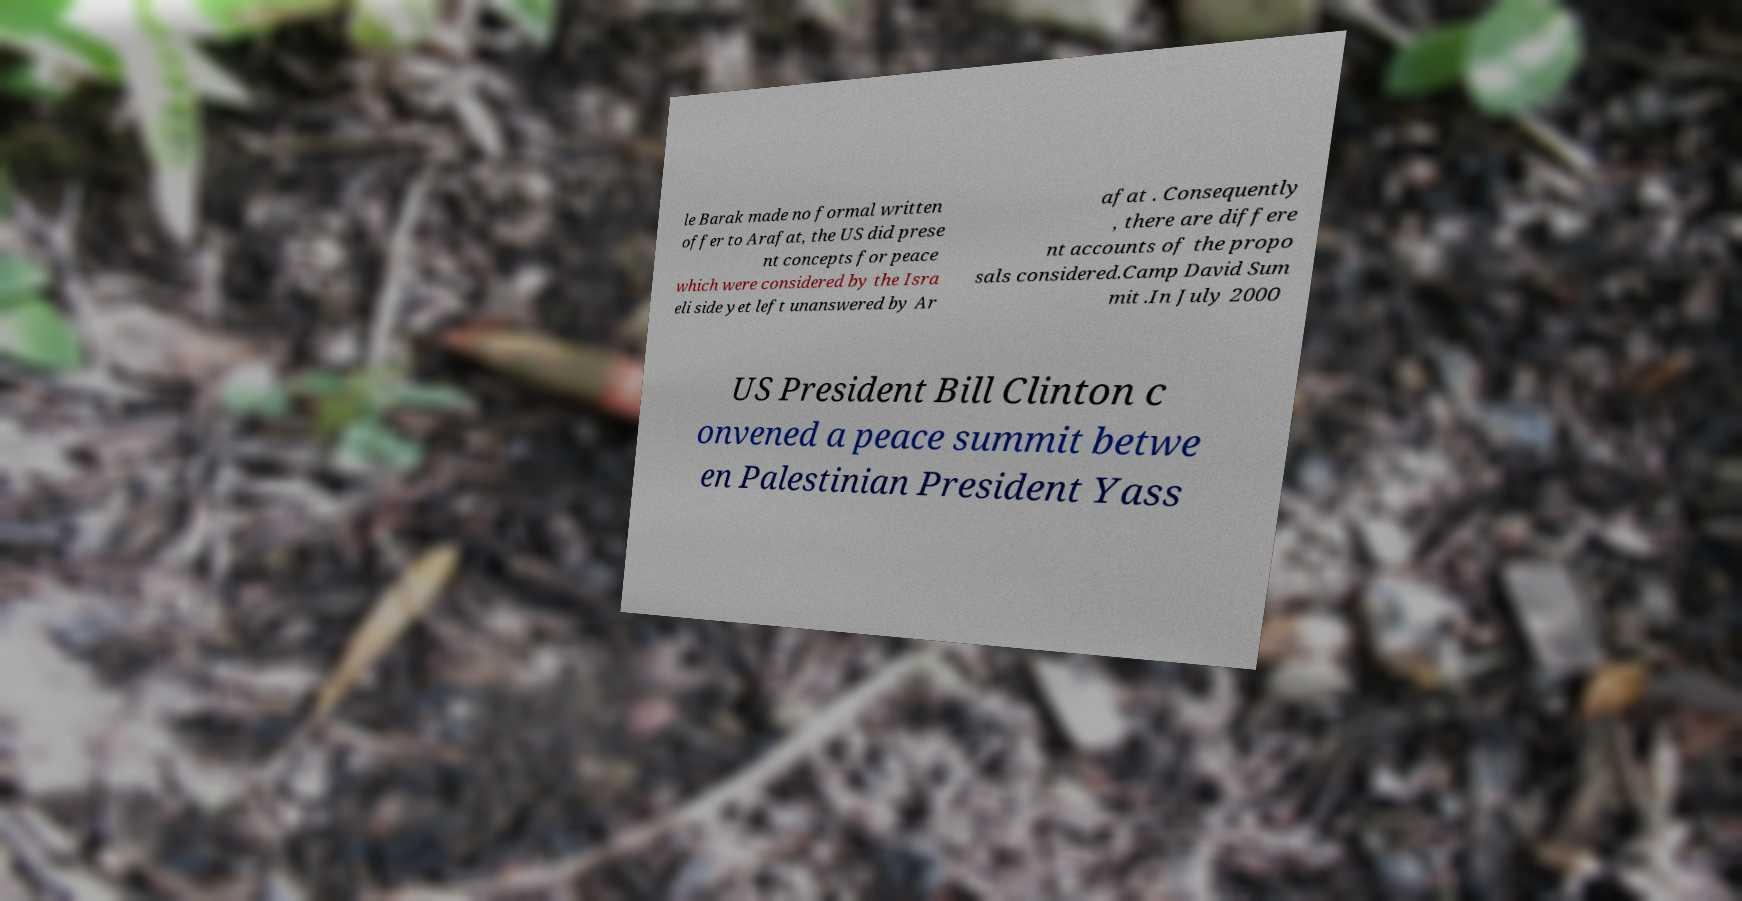What messages or text are displayed in this image? I need them in a readable, typed format. le Barak made no formal written offer to Arafat, the US did prese nt concepts for peace which were considered by the Isra eli side yet left unanswered by Ar afat . Consequently , there are differe nt accounts of the propo sals considered.Camp David Sum mit .In July 2000 US President Bill Clinton c onvened a peace summit betwe en Palestinian President Yass 